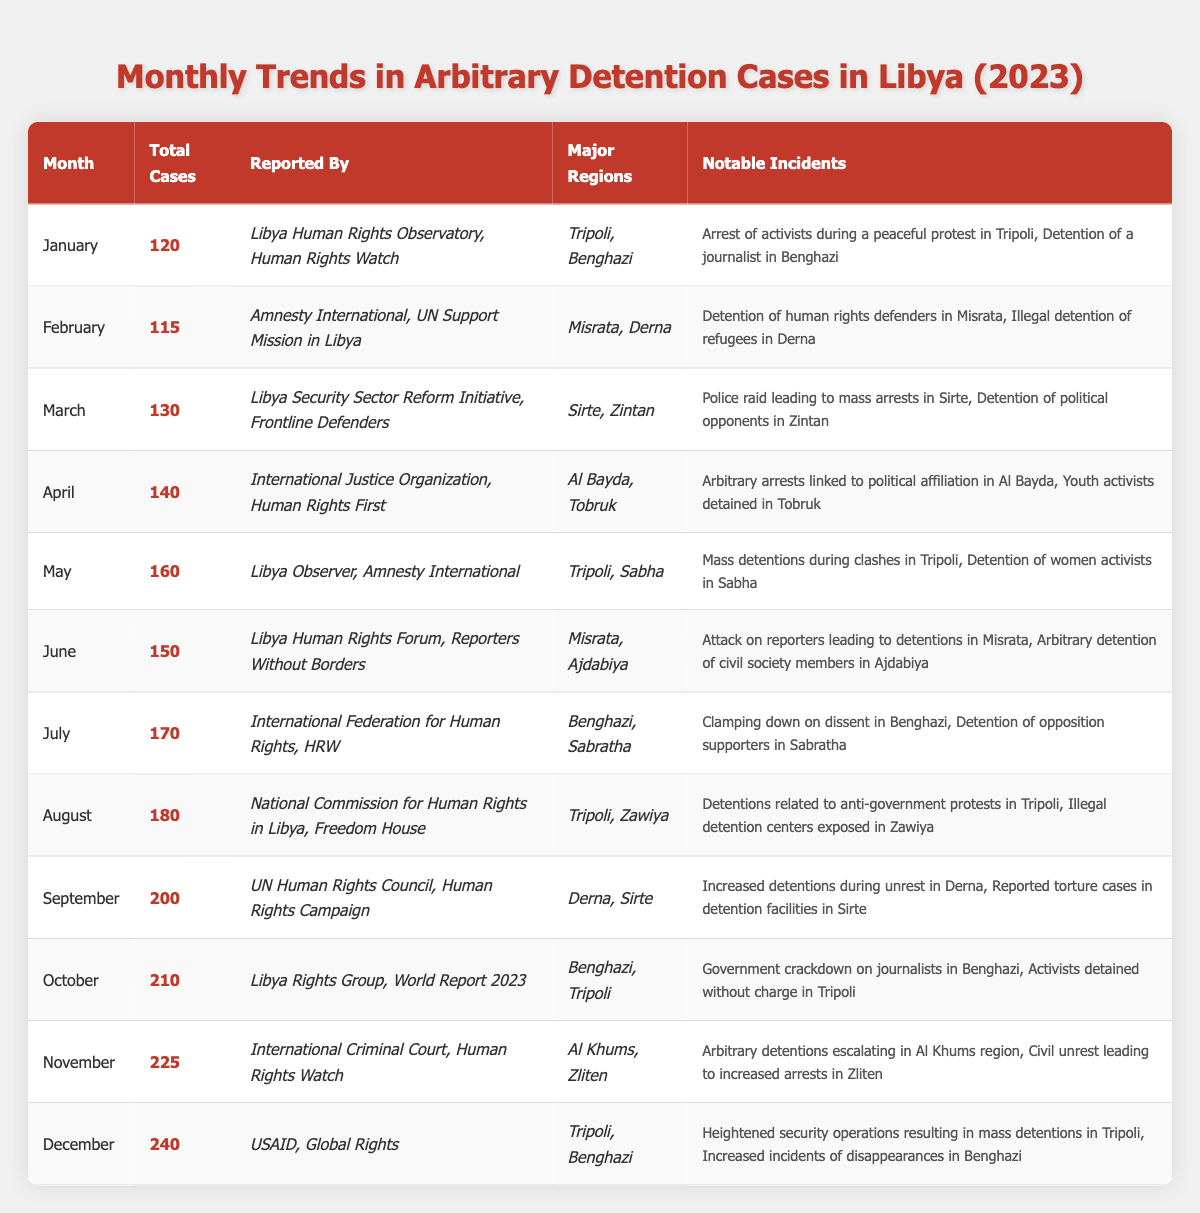What was the highest number of arbitrary detention cases reported in a month during 2023? The highest monthly total is found by scanning through the "Total Cases" column in the table. The maximum number recorded is 240 in December.
Answer: 240 Which organization reported the highest number of detention cases in November? Looking at the "Reported By" column for November, the organizations listed are "International Criminal Court" and "Human Rights Watch". Both reported, but the focus is on November which states the total number of cases without differentiating between organizations.
Answer: International Criminal Court and Human Rights Watch In which month were the most notable incidents linked to government crackdowns reported? Reviewing the notable incidents column, "government crackdown on journalists" is mentioned in October, which appears significant. There appears to be no other mention of government crackdowns in other months' notable incidents.
Answer: October How many months reported a total of more than 200 cases? The months with more than 200 cases are September (200), October (210), November (225), and December (240). Counting these months gives a total of four.
Answer: 4 Which month had the lowest total cases reported and what was it? Scanning the "Total Cases" column, the lowest month is February with 115 total cases.
Answer: February, 115 Identify the major regions where most arbitrary detentions took place in April. The "Major Regions" column for April shows "Al Bayda" and "Tobruk" as the locations where detentions occurred, highlighting these regions for that month.
Answer: Al Bayda, Tobruk What is the average number of arbitrary detention cases per month for 2023? To find the average, add all total cases for the year (totaling to 1,670) and divide by 12 months: 1,670 / 12 equals approximately 139.17.
Answer: 139.17 In which two months were Tripoli and Benghazi reported as major regions for arbitrary detention incidents? The rows for January and December both mention Tripoli and Benghazi as major regions, indicating detentions occurred in these places.
Answer: January, December Was there an increase or decrease in arbitrary detention cases from May to June? Assessing the total cases from May (160) to June (150) shows a decrease of 10 cases, indicating fewer detentions in June compared to May.
Answer: Decrease What notable incidents occurred in Misrata during June? The notable incidents for June mention "Attack on reporters leading to detentions in Misrata" and "Arbitrary detention of civil society members in Ajdabiya."
Answer: Attack on reporters leading to detentions 